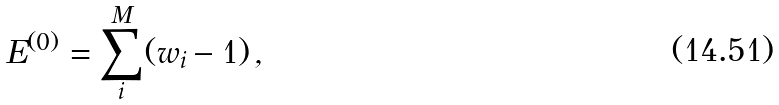Convert formula to latex. <formula><loc_0><loc_0><loc_500><loc_500>E ^ { ( 0 ) } = \sum _ { i } ^ { M } ( w _ { i } - 1 ) \, ,</formula> 